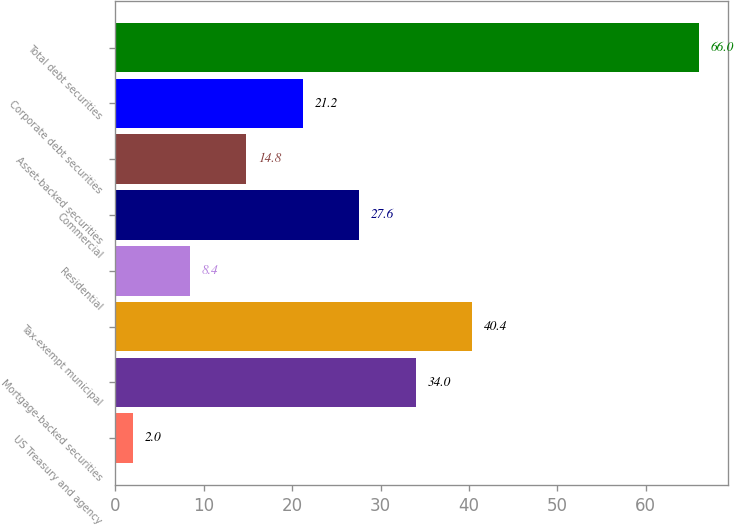<chart> <loc_0><loc_0><loc_500><loc_500><bar_chart><fcel>US Treasury and agency<fcel>Mortgage-backed securities<fcel>Tax-exempt municipal<fcel>Residential<fcel>Commercial<fcel>Asset-backed securities<fcel>Corporate debt securities<fcel>Total debt securities<nl><fcel>2<fcel>34<fcel>40.4<fcel>8.4<fcel>27.6<fcel>14.8<fcel>21.2<fcel>66<nl></chart> 